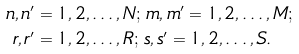Convert formula to latex. <formula><loc_0><loc_0><loc_500><loc_500>n , n ^ { \prime } & = 1 , 2 , \dots , N ; \, m , m ^ { \prime } = 1 , 2 , \dots , M ; \\ r , r ^ { \prime } & = 1 , 2 , \dots , R ; \, s , s ^ { \prime } = 1 , 2 , \dots , S .</formula> 